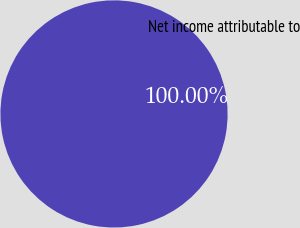<chart> <loc_0><loc_0><loc_500><loc_500><pie_chart><fcel>Net income attributable to<nl><fcel>100.0%<nl></chart> 